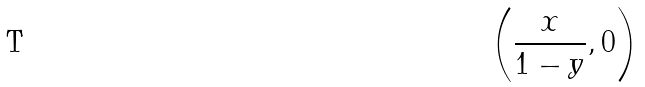<formula> <loc_0><loc_0><loc_500><loc_500>\left ( { \frac { x } { 1 - y } } , 0 \right )</formula> 